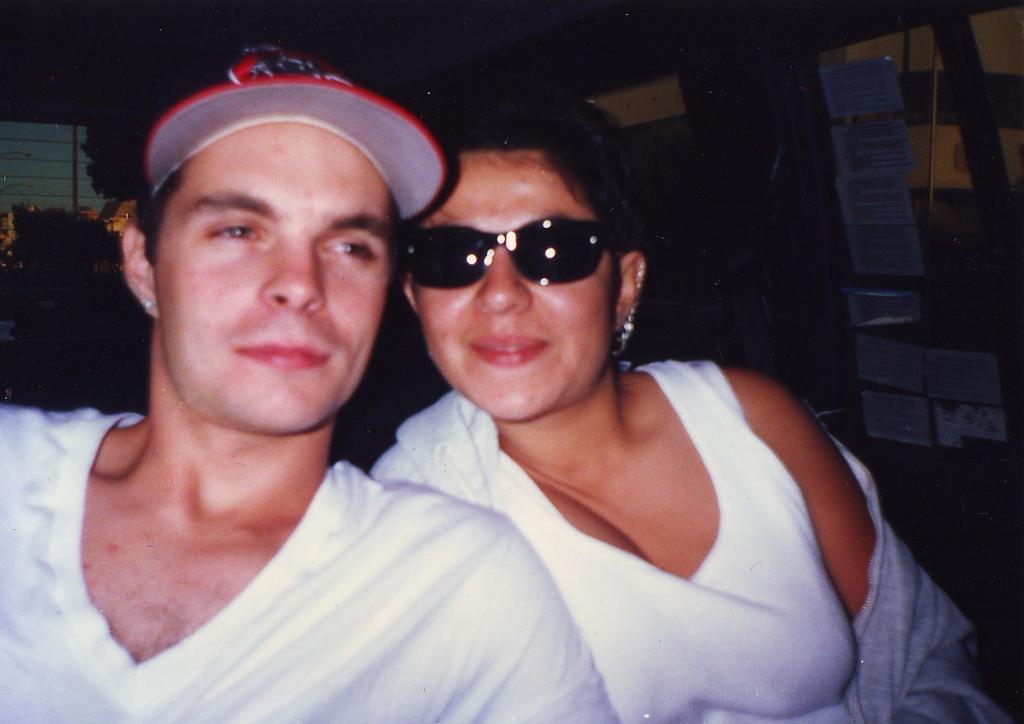How would you summarize this image in a sentence or two? In this image there is a couple in the middle. On the right side there is a glass on which there are papers. In the background it is dark. The man is wearing the cap while the woman is wearing the spectacles. 